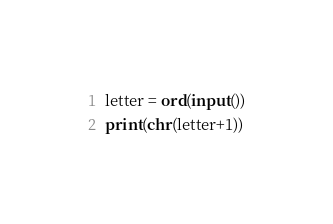Convert code to text. <code><loc_0><loc_0><loc_500><loc_500><_Python_>letter = ord(input())
print(chr(letter+1))</code> 